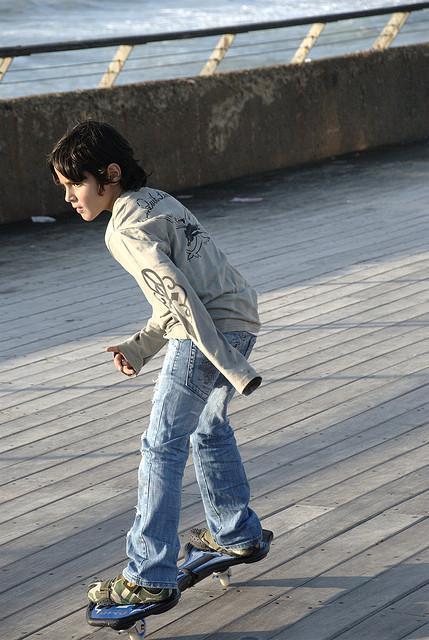How many skateboards are visible?
Give a very brief answer. 1. How many horses are in the photo?
Give a very brief answer. 0. 